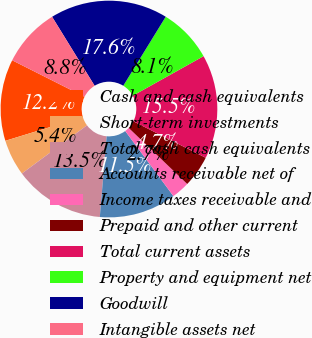<chart> <loc_0><loc_0><loc_500><loc_500><pie_chart><fcel>Cash and cash equivalents<fcel>Short-term investments<fcel>Total cash cash equivalents<fcel>Accounts receivable net of<fcel>Income taxes receivable and<fcel>Prepaid and other current<fcel>Total current assets<fcel>Property and equipment net<fcel>Goodwill<fcel>Intangible assets net<nl><fcel>12.16%<fcel>5.41%<fcel>13.51%<fcel>11.49%<fcel>2.7%<fcel>4.73%<fcel>15.54%<fcel>8.11%<fcel>17.57%<fcel>8.78%<nl></chart> 